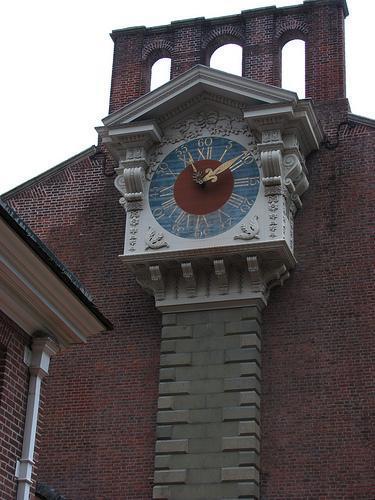How many clocks are pictured?
Give a very brief answer. 1. 